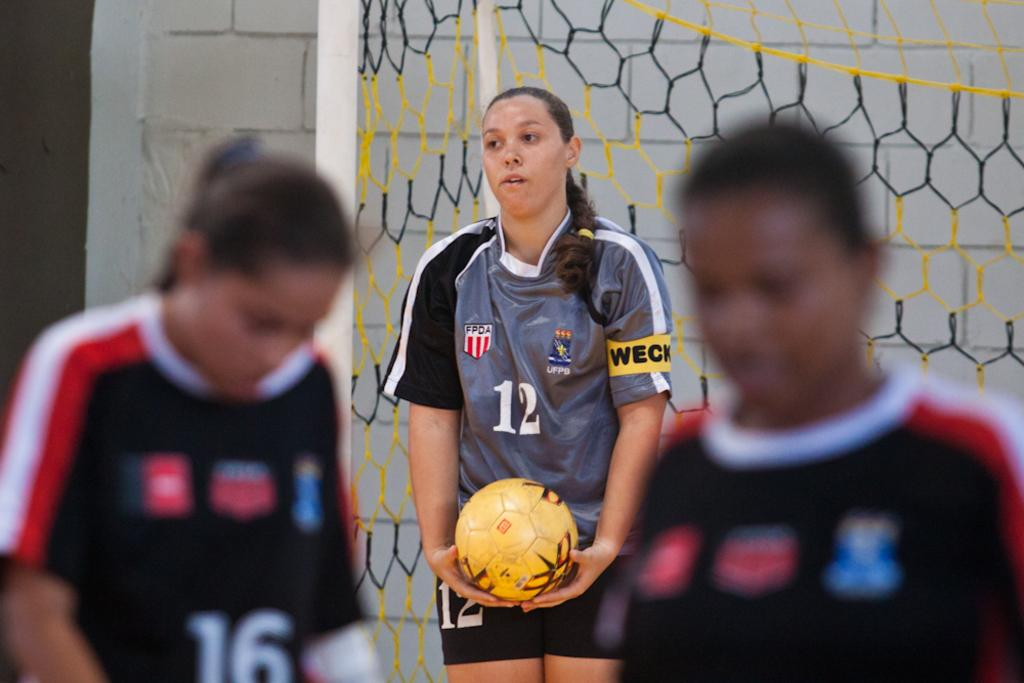Who are the subjects in the image? There are people in the image. What activity are the people engaged in? The people are playing football. What object is present in the image related to the game? There is a net visible in the image. What type of plastic material can be seen in the image? There is no plastic material present in the image. What knowledge is being gained by the people in the image? The image does not provide information about the knowledge being gained by the people; it only shows them playing football. 